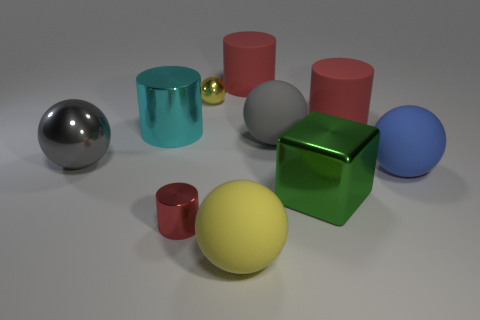What color is the large matte cylinder to the right of the big red cylinder that is left of the green object?
Your answer should be compact. Red. The large metallic cylinder has what color?
Your answer should be very brief. Cyan. Is there a large cylinder of the same color as the tiny ball?
Offer a very short reply. No. Is the color of the metallic sphere behind the gray metal thing the same as the large metal cylinder?
Make the answer very short. No. What number of things are balls that are behind the big gray rubber ball or large green blocks?
Provide a succinct answer. 2. Are there any large cyan metallic objects to the right of the big cyan shiny object?
Offer a terse response. No. There is a large object that is the same color as the tiny metal sphere; what is its material?
Offer a very short reply. Rubber. Is the material of the ball in front of the green object the same as the cyan cylinder?
Ensure brevity in your answer.  No. Are there any large cyan shiny objects that are in front of the metallic cylinder in front of the big gray thing that is to the left of the big yellow ball?
Provide a short and direct response. No. What number of balls are either big gray rubber objects or big gray things?
Give a very brief answer. 2. 